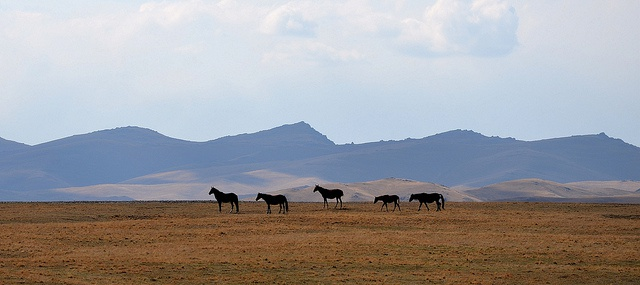Describe the objects in this image and their specific colors. I can see horse in lightgray, black, gray, and maroon tones, horse in lightgray, black, and gray tones, horse in lightgray, black, and gray tones, horse in lightgray, black, gray, and maroon tones, and horse in lightgray, black, maroon, and gray tones in this image. 